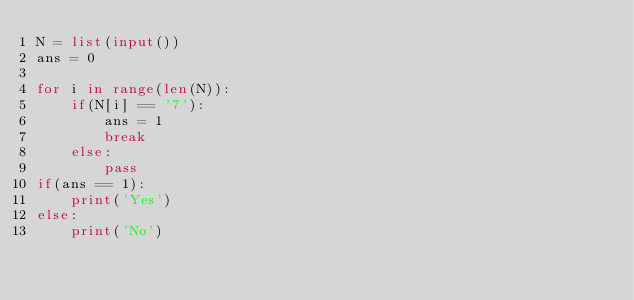<code> <loc_0><loc_0><loc_500><loc_500><_Python_>N = list(input())
ans = 0

for i in range(len(N)):
    if(N[i] == '7'):
        ans = 1
        break
    else:
        pass
if(ans == 1):
    print('Yes')
else:
    print('No')</code> 